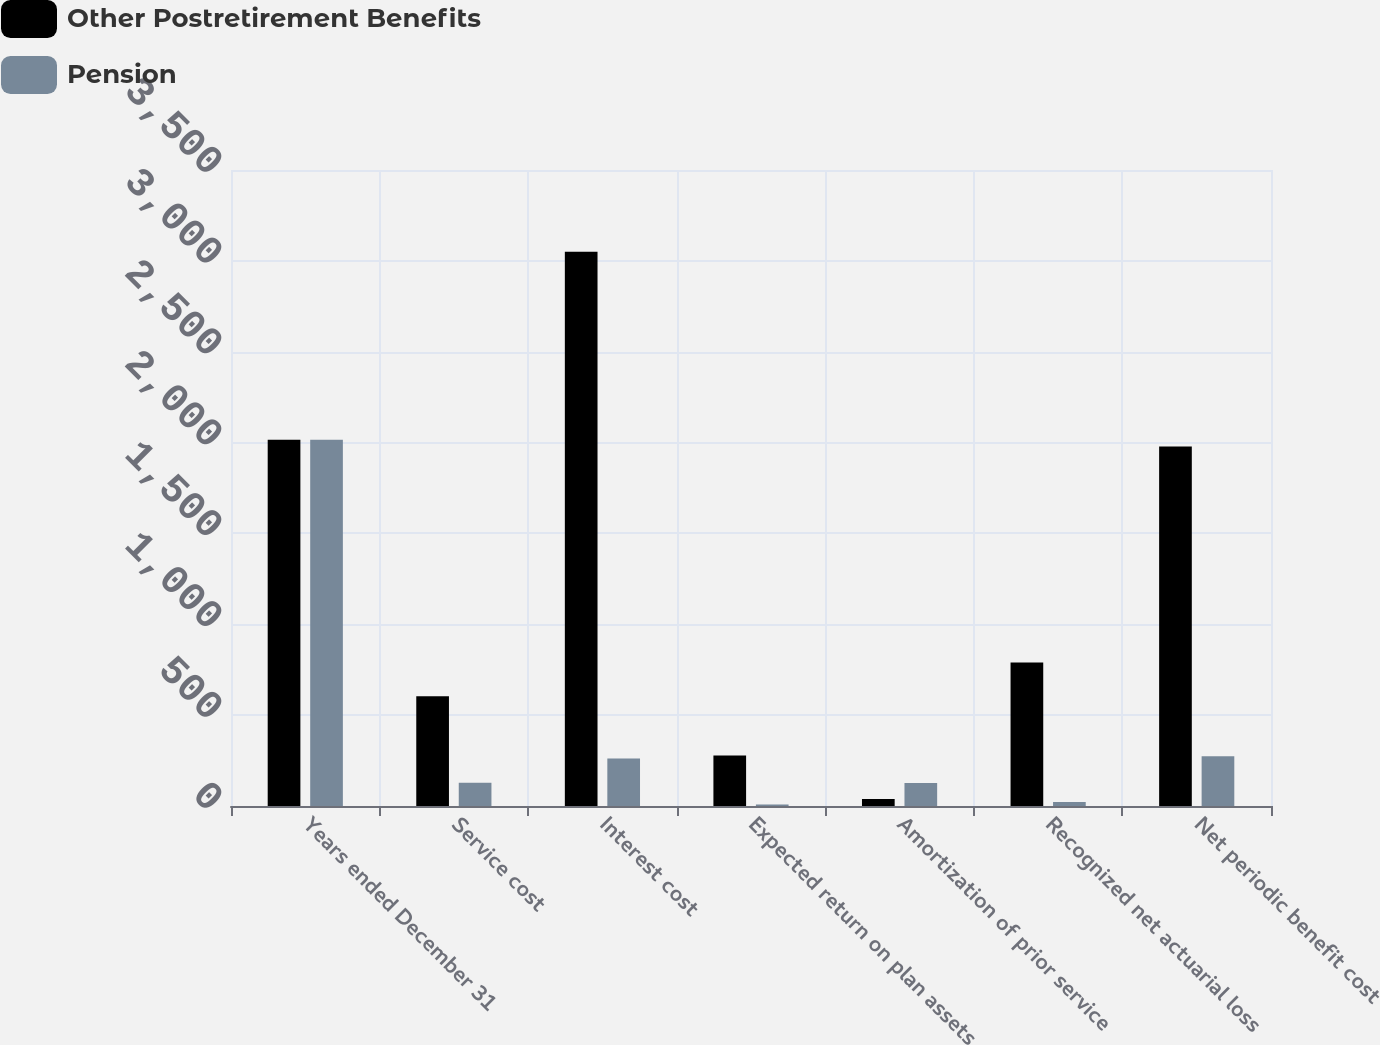Convert chart. <chart><loc_0><loc_0><loc_500><loc_500><stacked_bar_chart><ecel><fcel>Years ended December 31<fcel>Service cost<fcel>Interest cost<fcel>Expected return on plan assets<fcel>Amortization of prior service<fcel>Recognized net actuarial loss<fcel>Net periodic benefit cost<nl><fcel>Other Postretirement Benefits<fcel>2016<fcel>604<fcel>3050<fcel>278<fcel>38<fcel>790<fcel>1979<nl><fcel>Pension<fcel>2016<fcel>128<fcel>262<fcel>8<fcel>126<fcel>22<fcel>274<nl></chart> 